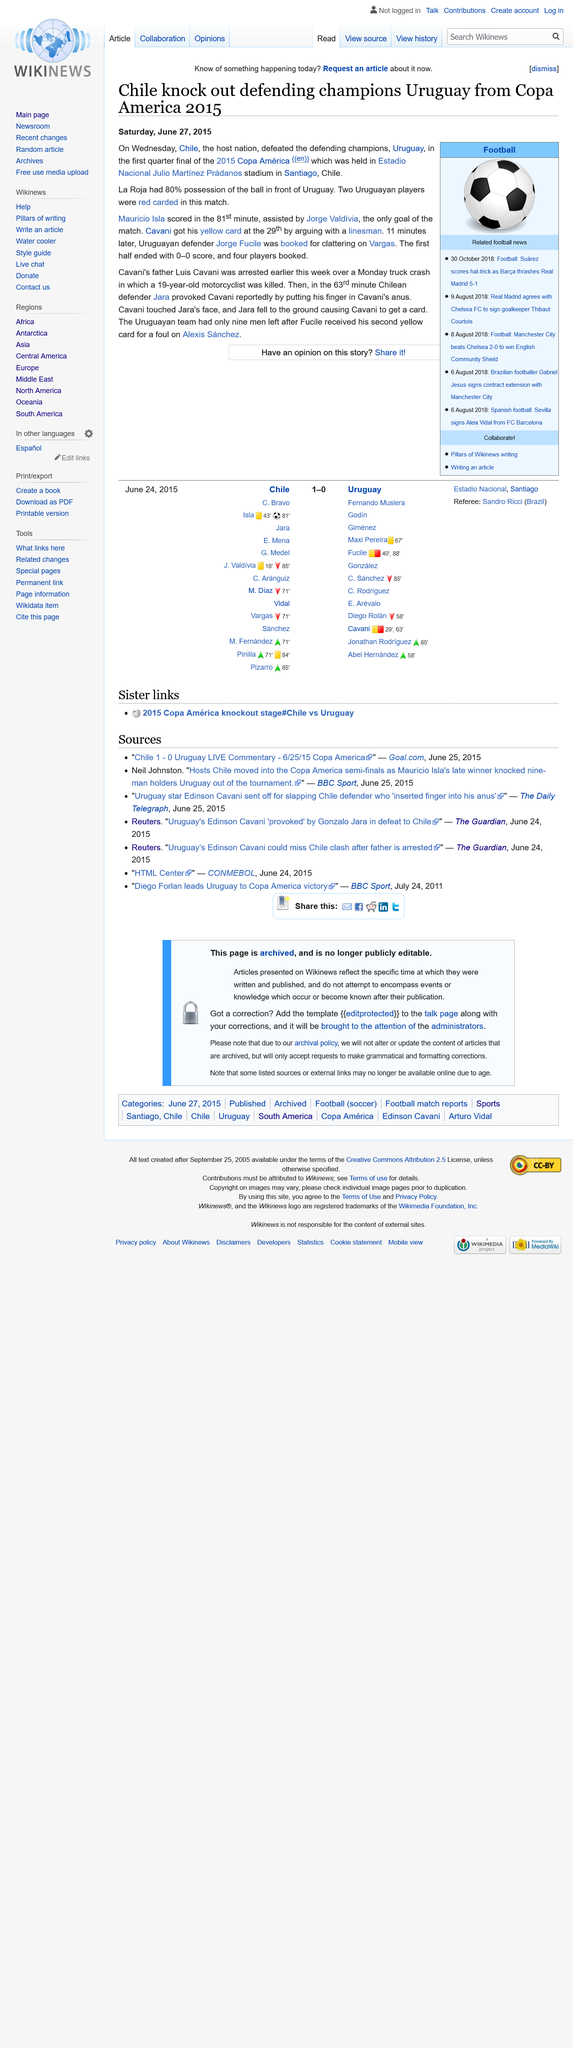Point out several critical features in this image. La Roja had 80% possession of the ball for a significant portion of the match. On Wednesday June 24, 2015, Chile defeated Uruguay in the quarter final of the 2015 Copa America, a significant victory that cemented their place in the history of the tournament. This landmark match, which took place at the iconic Estadio Nacional in Santiago, Chile, was a hard-fought battle between two formidable footballing nations, with both teams giving it their all on the pitch. Chile ultimately emerged victorious, thanks to their strong teamwork, tactical nous, and unwavering commitment to their cause, setting the stage for their eventual triumph in the tournament final against Argentina. 